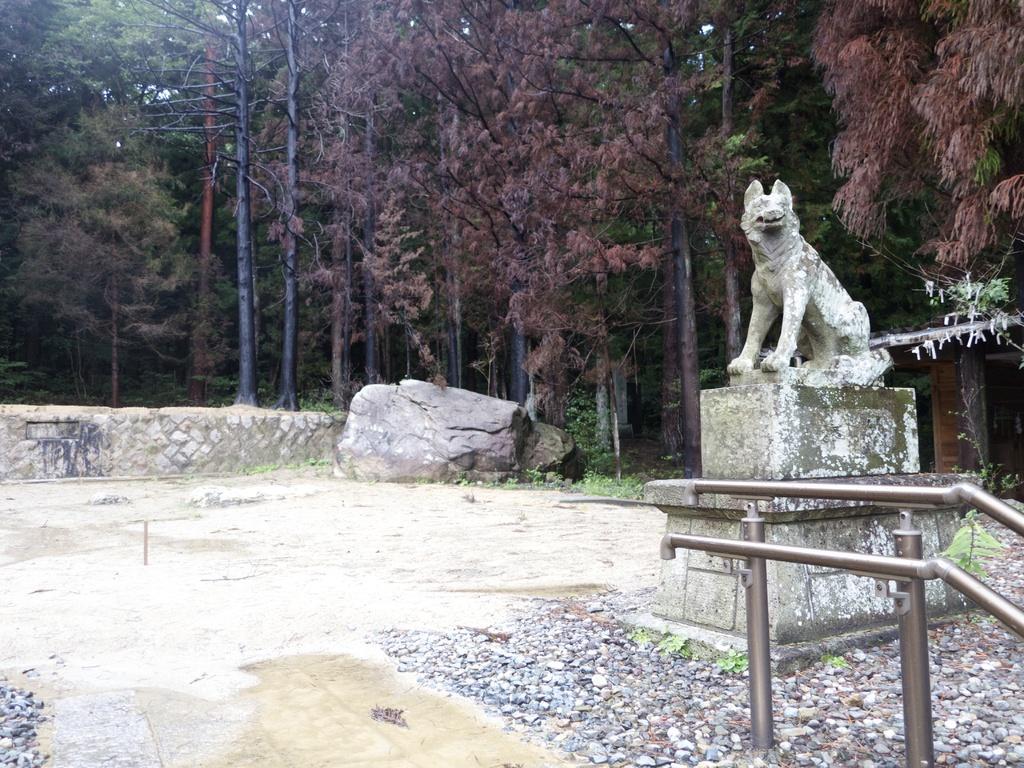Can you describe this image briefly? In this image we can see an animal statue. We can also see the stones, ground, rock and also the wall. In the background we can see many trees. On the right we can see the roof for shelter. We can also see the railing. 